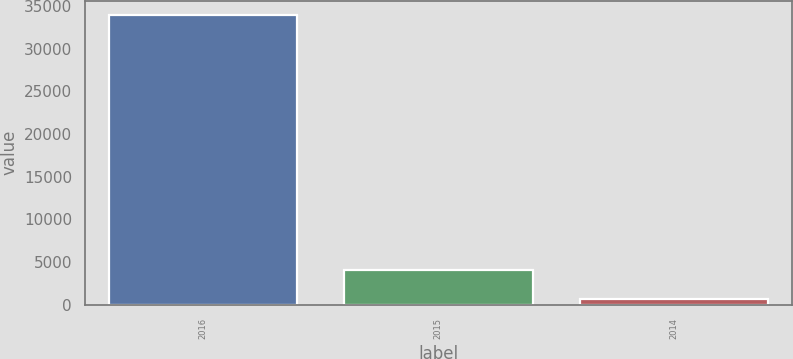Convert chart. <chart><loc_0><loc_0><loc_500><loc_500><bar_chart><fcel>2016<fcel>2015<fcel>2014<nl><fcel>33917<fcel>4064<fcel>747<nl></chart> 